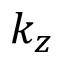<formula> <loc_0><loc_0><loc_500><loc_500>k _ { z }</formula> 